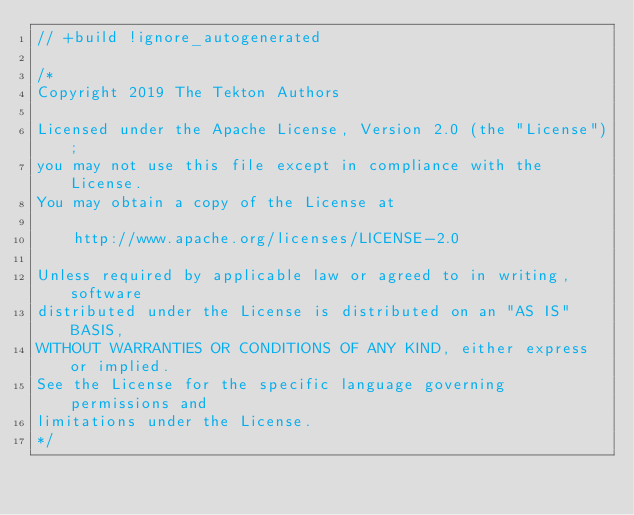<code> <loc_0><loc_0><loc_500><loc_500><_Go_>// +build !ignore_autogenerated

/*
Copyright 2019 The Tekton Authors

Licensed under the Apache License, Version 2.0 (the "License");
you may not use this file except in compliance with the License.
You may obtain a copy of the License at

    http://www.apache.org/licenses/LICENSE-2.0

Unless required by applicable law or agreed to in writing, software
distributed under the License is distributed on an "AS IS" BASIS,
WITHOUT WARRANTIES OR CONDITIONS OF ANY KIND, either express or implied.
See the License for the specific language governing permissions and
limitations under the License.
*/
</code> 